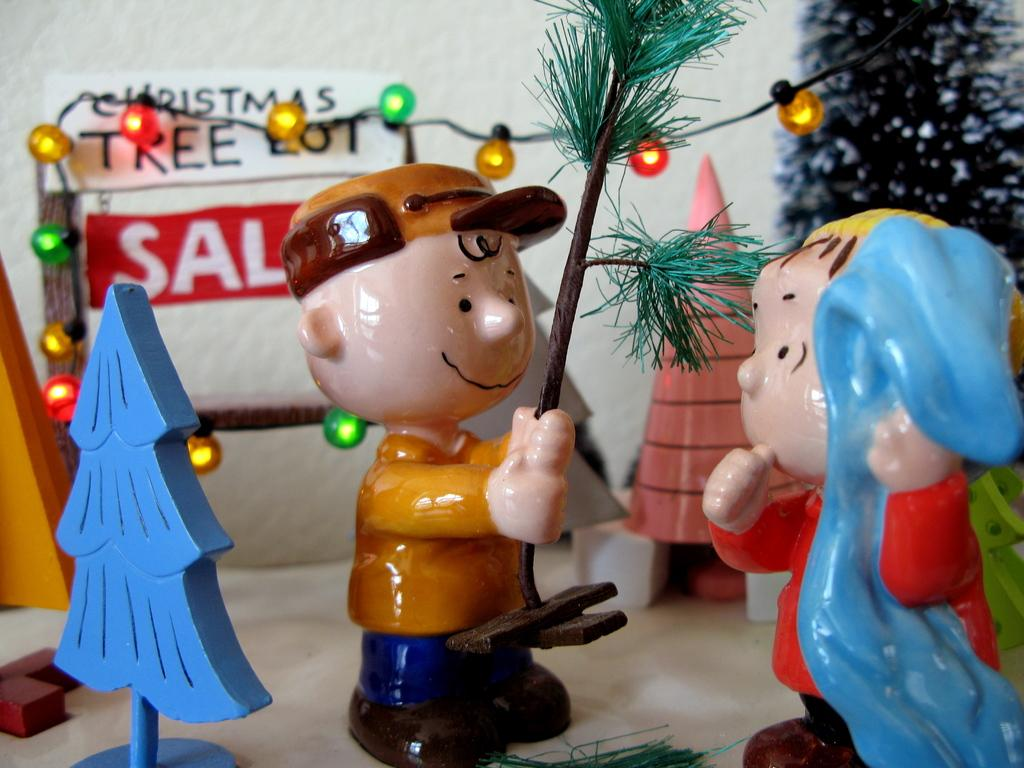What can be seen in the foreground of the picture? There are toys, a light, and other objects in the foreground of the picture. Can you describe the light in the foreground? The light is visible in the foreground of the picture. What is visible in the background of the picture? There is a wall visible in the background of the picture. Where is the robin perched in the image? There is no robin present in the image. What type of cellar can be seen in the image? There is no cellar present in the image. 